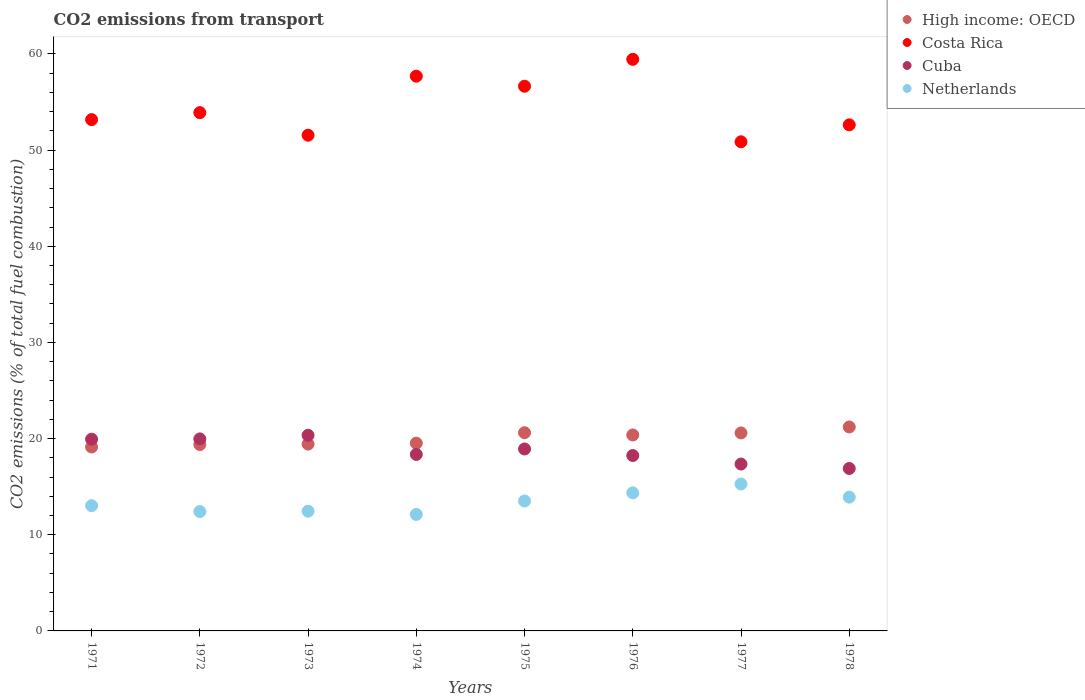What is the total CO2 emitted in High income: OECD in 1978?
Offer a very short reply. 21.21. Across all years, what is the maximum total CO2 emitted in Cuba?
Make the answer very short. 20.34. Across all years, what is the minimum total CO2 emitted in Cuba?
Give a very brief answer. 16.89. In which year was the total CO2 emitted in Costa Rica maximum?
Keep it short and to the point. 1976. In which year was the total CO2 emitted in Netherlands minimum?
Your answer should be compact. 1974. What is the total total CO2 emitted in High income: OECD in the graph?
Ensure brevity in your answer.  160.26. What is the difference between the total CO2 emitted in Netherlands in 1977 and that in 1978?
Offer a very short reply. 1.37. What is the difference between the total CO2 emitted in Netherlands in 1973 and the total CO2 emitted in High income: OECD in 1975?
Keep it short and to the point. -8.16. What is the average total CO2 emitted in Netherlands per year?
Provide a succinct answer. 13.38. In the year 1973, what is the difference between the total CO2 emitted in High income: OECD and total CO2 emitted in Cuba?
Keep it short and to the point. -0.92. What is the ratio of the total CO2 emitted in Netherlands in 1973 to that in 1974?
Ensure brevity in your answer.  1.03. Is the total CO2 emitted in Netherlands in 1974 less than that in 1975?
Offer a terse response. Yes. Is the difference between the total CO2 emitted in High income: OECD in 1974 and 1975 greater than the difference between the total CO2 emitted in Cuba in 1974 and 1975?
Offer a very short reply. No. What is the difference between the highest and the second highest total CO2 emitted in Netherlands?
Offer a very short reply. 0.92. What is the difference between the highest and the lowest total CO2 emitted in Costa Rica?
Your response must be concise. 8.57. Does the total CO2 emitted in Netherlands monotonically increase over the years?
Your answer should be compact. No. Is the total CO2 emitted in Cuba strictly less than the total CO2 emitted in Costa Rica over the years?
Provide a succinct answer. Yes. How many dotlines are there?
Keep it short and to the point. 4. How many years are there in the graph?
Ensure brevity in your answer.  8. What is the difference between two consecutive major ticks on the Y-axis?
Provide a short and direct response. 10. Does the graph contain grids?
Your answer should be compact. No. How many legend labels are there?
Provide a succinct answer. 4. What is the title of the graph?
Your answer should be compact. CO2 emissions from transport. Does "Euro area" appear as one of the legend labels in the graph?
Make the answer very short. No. What is the label or title of the X-axis?
Ensure brevity in your answer.  Years. What is the label or title of the Y-axis?
Provide a succinct answer. CO2 emissions (% of total fuel combustion). What is the CO2 emissions (% of total fuel combustion) of High income: OECD in 1971?
Provide a succinct answer. 19.13. What is the CO2 emissions (% of total fuel combustion) of Costa Rica in 1971?
Keep it short and to the point. 53.17. What is the CO2 emissions (% of total fuel combustion) in Cuba in 1971?
Your answer should be very brief. 19.94. What is the CO2 emissions (% of total fuel combustion) in Netherlands in 1971?
Keep it short and to the point. 13.03. What is the CO2 emissions (% of total fuel combustion) in High income: OECD in 1972?
Provide a succinct answer. 19.38. What is the CO2 emissions (% of total fuel combustion) in Costa Rica in 1972?
Make the answer very short. 53.9. What is the CO2 emissions (% of total fuel combustion) in Cuba in 1972?
Your response must be concise. 19.97. What is the CO2 emissions (% of total fuel combustion) of Netherlands in 1972?
Offer a very short reply. 12.41. What is the CO2 emissions (% of total fuel combustion) in High income: OECD in 1973?
Offer a terse response. 19.43. What is the CO2 emissions (% of total fuel combustion) in Costa Rica in 1973?
Offer a terse response. 51.55. What is the CO2 emissions (% of total fuel combustion) of Cuba in 1973?
Provide a succinct answer. 20.34. What is the CO2 emissions (% of total fuel combustion) in Netherlands in 1973?
Provide a succinct answer. 12.45. What is the CO2 emissions (% of total fuel combustion) in High income: OECD in 1974?
Your answer should be very brief. 19.52. What is the CO2 emissions (% of total fuel combustion) of Costa Rica in 1974?
Provide a succinct answer. 57.69. What is the CO2 emissions (% of total fuel combustion) of Cuba in 1974?
Your response must be concise. 18.35. What is the CO2 emissions (% of total fuel combustion) in Netherlands in 1974?
Your answer should be very brief. 12.12. What is the CO2 emissions (% of total fuel combustion) of High income: OECD in 1975?
Provide a short and direct response. 20.61. What is the CO2 emissions (% of total fuel combustion) of Costa Rica in 1975?
Your response must be concise. 56.65. What is the CO2 emissions (% of total fuel combustion) in Cuba in 1975?
Your response must be concise. 18.92. What is the CO2 emissions (% of total fuel combustion) of Netherlands in 1975?
Provide a short and direct response. 13.51. What is the CO2 emissions (% of total fuel combustion) of High income: OECD in 1976?
Provide a short and direct response. 20.38. What is the CO2 emissions (% of total fuel combustion) in Costa Rica in 1976?
Ensure brevity in your answer.  59.44. What is the CO2 emissions (% of total fuel combustion) in Cuba in 1976?
Provide a succinct answer. 18.24. What is the CO2 emissions (% of total fuel combustion) in Netherlands in 1976?
Keep it short and to the point. 14.36. What is the CO2 emissions (% of total fuel combustion) of High income: OECD in 1977?
Make the answer very short. 20.59. What is the CO2 emissions (% of total fuel combustion) of Costa Rica in 1977?
Your answer should be very brief. 50.87. What is the CO2 emissions (% of total fuel combustion) of Cuba in 1977?
Your answer should be compact. 17.35. What is the CO2 emissions (% of total fuel combustion) in Netherlands in 1977?
Your answer should be compact. 15.28. What is the CO2 emissions (% of total fuel combustion) in High income: OECD in 1978?
Offer a very short reply. 21.21. What is the CO2 emissions (% of total fuel combustion) in Costa Rica in 1978?
Your response must be concise. 52.63. What is the CO2 emissions (% of total fuel combustion) in Cuba in 1978?
Provide a short and direct response. 16.89. What is the CO2 emissions (% of total fuel combustion) of Netherlands in 1978?
Make the answer very short. 13.91. Across all years, what is the maximum CO2 emissions (% of total fuel combustion) of High income: OECD?
Your response must be concise. 21.21. Across all years, what is the maximum CO2 emissions (% of total fuel combustion) in Costa Rica?
Your answer should be very brief. 59.44. Across all years, what is the maximum CO2 emissions (% of total fuel combustion) of Cuba?
Give a very brief answer. 20.34. Across all years, what is the maximum CO2 emissions (% of total fuel combustion) in Netherlands?
Make the answer very short. 15.28. Across all years, what is the minimum CO2 emissions (% of total fuel combustion) in High income: OECD?
Offer a very short reply. 19.13. Across all years, what is the minimum CO2 emissions (% of total fuel combustion) of Costa Rica?
Provide a short and direct response. 50.87. Across all years, what is the minimum CO2 emissions (% of total fuel combustion) of Cuba?
Your response must be concise. 16.89. Across all years, what is the minimum CO2 emissions (% of total fuel combustion) in Netherlands?
Give a very brief answer. 12.12. What is the total CO2 emissions (% of total fuel combustion) of High income: OECD in the graph?
Provide a short and direct response. 160.26. What is the total CO2 emissions (% of total fuel combustion) of Costa Rica in the graph?
Your answer should be compact. 435.91. What is the total CO2 emissions (% of total fuel combustion) of Cuba in the graph?
Offer a terse response. 150.02. What is the total CO2 emissions (% of total fuel combustion) of Netherlands in the graph?
Offer a terse response. 107.07. What is the difference between the CO2 emissions (% of total fuel combustion) in High income: OECD in 1971 and that in 1972?
Keep it short and to the point. -0.25. What is the difference between the CO2 emissions (% of total fuel combustion) in Costa Rica in 1971 and that in 1972?
Make the answer very short. -0.73. What is the difference between the CO2 emissions (% of total fuel combustion) in Cuba in 1971 and that in 1972?
Make the answer very short. -0.03. What is the difference between the CO2 emissions (% of total fuel combustion) in Netherlands in 1971 and that in 1972?
Give a very brief answer. 0.61. What is the difference between the CO2 emissions (% of total fuel combustion) of Costa Rica in 1971 and that in 1973?
Your answer should be very brief. 1.62. What is the difference between the CO2 emissions (% of total fuel combustion) of Cuba in 1971 and that in 1973?
Offer a very short reply. -0.4. What is the difference between the CO2 emissions (% of total fuel combustion) in Netherlands in 1971 and that in 1973?
Your answer should be very brief. 0.58. What is the difference between the CO2 emissions (% of total fuel combustion) of High income: OECD in 1971 and that in 1974?
Offer a terse response. -0.4. What is the difference between the CO2 emissions (% of total fuel combustion) of Costa Rica in 1971 and that in 1974?
Keep it short and to the point. -4.52. What is the difference between the CO2 emissions (% of total fuel combustion) of Cuba in 1971 and that in 1974?
Give a very brief answer. 1.59. What is the difference between the CO2 emissions (% of total fuel combustion) of Netherlands in 1971 and that in 1974?
Your response must be concise. 0.91. What is the difference between the CO2 emissions (% of total fuel combustion) in High income: OECD in 1971 and that in 1975?
Offer a very short reply. -1.49. What is the difference between the CO2 emissions (% of total fuel combustion) of Costa Rica in 1971 and that in 1975?
Provide a succinct answer. -3.47. What is the difference between the CO2 emissions (% of total fuel combustion) of Cuba in 1971 and that in 1975?
Keep it short and to the point. 1.02. What is the difference between the CO2 emissions (% of total fuel combustion) in Netherlands in 1971 and that in 1975?
Make the answer very short. -0.48. What is the difference between the CO2 emissions (% of total fuel combustion) in High income: OECD in 1971 and that in 1976?
Ensure brevity in your answer.  -1.25. What is the difference between the CO2 emissions (% of total fuel combustion) of Costa Rica in 1971 and that in 1976?
Make the answer very short. -6.27. What is the difference between the CO2 emissions (% of total fuel combustion) of Cuba in 1971 and that in 1976?
Offer a very short reply. 1.7. What is the difference between the CO2 emissions (% of total fuel combustion) in Netherlands in 1971 and that in 1976?
Provide a succinct answer. -1.33. What is the difference between the CO2 emissions (% of total fuel combustion) of High income: OECD in 1971 and that in 1977?
Offer a very short reply. -1.46. What is the difference between the CO2 emissions (% of total fuel combustion) in Costa Rica in 1971 and that in 1977?
Provide a short and direct response. 2.31. What is the difference between the CO2 emissions (% of total fuel combustion) in Cuba in 1971 and that in 1977?
Keep it short and to the point. 2.59. What is the difference between the CO2 emissions (% of total fuel combustion) in Netherlands in 1971 and that in 1977?
Offer a very short reply. -2.25. What is the difference between the CO2 emissions (% of total fuel combustion) in High income: OECD in 1971 and that in 1978?
Provide a short and direct response. -2.08. What is the difference between the CO2 emissions (% of total fuel combustion) in Costa Rica in 1971 and that in 1978?
Keep it short and to the point. 0.54. What is the difference between the CO2 emissions (% of total fuel combustion) of Cuba in 1971 and that in 1978?
Offer a terse response. 3.05. What is the difference between the CO2 emissions (% of total fuel combustion) in Netherlands in 1971 and that in 1978?
Make the answer very short. -0.88. What is the difference between the CO2 emissions (% of total fuel combustion) of High income: OECD in 1972 and that in 1973?
Ensure brevity in your answer.  -0.05. What is the difference between the CO2 emissions (% of total fuel combustion) of Costa Rica in 1972 and that in 1973?
Keep it short and to the point. 2.35. What is the difference between the CO2 emissions (% of total fuel combustion) of Cuba in 1972 and that in 1973?
Make the answer very short. -0.37. What is the difference between the CO2 emissions (% of total fuel combustion) of Netherlands in 1972 and that in 1973?
Ensure brevity in your answer.  -0.04. What is the difference between the CO2 emissions (% of total fuel combustion) of High income: OECD in 1972 and that in 1974?
Give a very brief answer. -0.14. What is the difference between the CO2 emissions (% of total fuel combustion) in Costa Rica in 1972 and that in 1974?
Provide a short and direct response. -3.79. What is the difference between the CO2 emissions (% of total fuel combustion) in Cuba in 1972 and that in 1974?
Give a very brief answer. 1.62. What is the difference between the CO2 emissions (% of total fuel combustion) in Netherlands in 1972 and that in 1974?
Your answer should be very brief. 0.3. What is the difference between the CO2 emissions (% of total fuel combustion) in High income: OECD in 1972 and that in 1975?
Keep it short and to the point. -1.23. What is the difference between the CO2 emissions (% of total fuel combustion) of Costa Rica in 1972 and that in 1975?
Provide a short and direct response. -2.75. What is the difference between the CO2 emissions (% of total fuel combustion) of Cuba in 1972 and that in 1975?
Your answer should be very brief. 1.05. What is the difference between the CO2 emissions (% of total fuel combustion) of Netherlands in 1972 and that in 1975?
Make the answer very short. -1.1. What is the difference between the CO2 emissions (% of total fuel combustion) of High income: OECD in 1972 and that in 1976?
Offer a very short reply. -1. What is the difference between the CO2 emissions (% of total fuel combustion) in Costa Rica in 1972 and that in 1976?
Your answer should be compact. -5.54. What is the difference between the CO2 emissions (% of total fuel combustion) in Cuba in 1972 and that in 1976?
Ensure brevity in your answer.  1.73. What is the difference between the CO2 emissions (% of total fuel combustion) in Netherlands in 1972 and that in 1976?
Your answer should be very brief. -1.95. What is the difference between the CO2 emissions (% of total fuel combustion) in High income: OECD in 1972 and that in 1977?
Give a very brief answer. -1.21. What is the difference between the CO2 emissions (% of total fuel combustion) of Costa Rica in 1972 and that in 1977?
Keep it short and to the point. 3.03. What is the difference between the CO2 emissions (% of total fuel combustion) of Cuba in 1972 and that in 1977?
Your answer should be compact. 2.62. What is the difference between the CO2 emissions (% of total fuel combustion) in Netherlands in 1972 and that in 1977?
Your answer should be very brief. -2.86. What is the difference between the CO2 emissions (% of total fuel combustion) of High income: OECD in 1972 and that in 1978?
Your answer should be compact. -1.83. What is the difference between the CO2 emissions (% of total fuel combustion) of Costa Rica in 1972 and that in 1978?
Your answer should be compact. 1.27. What is the difference between the CO2 emissions (% of total fuel combustion) of Cuba in 1972 and that in 1978?
Keep it short and to the point. 3.08. What is the difference between the CO2 emissions (% of total fuel combustion) of Netherlands in 1972 and that in 1978?
Ensure brevity in your answer.  -1.5. What is the difference between the CO2 emissions (% of total fuel combustion) in High income: OECD in 1973 and that in 1974?
Keep it short and to the point. -0.1. What is the difference between the CO2 emissions (% of total fuel combustion) in Costa Rica in 1973 and that in 1974?
Offer a very short reply. -6.14. What is the difference between the CO2 emissions (% of total fuel combustion) of Cuba in 1973 and that in 1974?
Keep it short and to the point. 1.99. What is the difference between the CO2 emissions (% of total fuel combustion) of Netherlands in 1973 and that in 1974?
Provide a short and direct response. 0.33. What is the difference between the CO2 emissions (% of total fuel combustion) of High income: OECD in 1973 and that in 1975?
Provide a short and direct response. -1.19. What is the difference between the CO2 emissions (% of total fuel combustion) of Costa Rica in 1973 and that in 1975?
Give a very brief answer. -5.09. What is the difference between the CO2 emissions (% of total fuel combustion) in Cuba in 1973 and that in 1975?
Your answer should be compact. 1.42. What is the difference between the CO2 emissions (% of total fuel combustion) in Netherlands in 1973 and that in 1975?
Offer a terse response. -1.06. What is the difference between the CO2 emissions (% of total fuel combustion) of High income: OECD in 1973 and that in 1976?
Offer a very short reply. -0.95. What is the difference between the CO2 emissions (% of total fuel combustion) in Costa Rica in 1973 and that in 1976?
Your answer should be very brief. -7.89. What is the difference between the CO2 emissions (% of total fuel combustion) of Cuba in 1973 and that in 1976?
Your response must be concise. 2.1. What is the difference between the CO2 emissions (% of total fuel combustion) in Netherlands in 1973 and that in 1976?
Your answer should be compact. -1.91. What is the difference between the CO2 emissions (% of total fuel combustion) in High income: OECD in 1973 and that in 1977?
Provide a succinct answer. -1.16. What is the difference between the CO2 emissions (% of total fuel combustion) in Costa Rica in 1973 and that in 1977?
Offer a terse response. 0.68. What is the difference between the CO2 emissions (% of total fuel combustion) in Cuba in 1973 and that in 1977?
Provide a short and direct response. 2.99. What is the difference between the CO2 emissions (% of total fuel combustion) of Netherlands in 1973 and that in 1977?
Your answer should be very brief. -2.83. What is the difference between the CO2 emissions (% of total fuel combustion) of High income: OECD in 1973 and that in 1978?
Your response must be concise. -1.78. What is the difference between the CO2 emissions (% of total fuel combustion) of Costa Rica in 1973 and that in 1978?
Offer a very short reply. -1.08. What is the difference between the CO2 emissions (% of total fuel combustion) in Cuba in 1973 and that in 1978?
Offer a terse response. 3.45. What is the difference between the CO2 emissions (% of total fuel combustion) in Netherlands in 1973 and that in 1978?
Provide a short and direct response. -1.46. What is the difference between the CO2 emissions (% of total fuel combustion) in High income: OECD in 1974 and that in 1975?
Your response must be concise. -1.09. What is the difference between the CO2 emissions (% of total fuel combustion) of Costa Rica in 1974 and that in 1975?
Offer a very short reply. 1.04. What is the difference between the CO2 emissions (% of total fuel combustion) of Cuba in 1974 and that in 1975?
Your answer should be very brief. -0.57. What is the difference between the CO2 emissions (% of total fuel combustion) of Netherlands in 1974 and that in 1975?
Offer a terse response. -1.4. What is the difference between the CO2 emissions (% of total fuel combustion) of High income: OECD in 1974 and that in 1976?
Your answer should be compact. -0.85. What is the difference between the CO2 emissions (% of total fuel combustion) of Costa Rica in 1974 and that in 1976?
Your response must be concise. -1.75. What is the difference between the CO2 emissions (% of total fuel combustion) in Cuba in 1974 and that in 1976?
Provide a succinct answer. 0.11. What is the difference between the CO2 emissions (% of total fuel combustion) in Netherlands in 1974 and that in 1976?
Offer a terse response. -2.24. What is the difference between the CO2 emissions (% of total fuel combustion) of High income: OECD in 1974 and that in 1977?
Your response must be concise. -1.07. What is the difference between the CO2 emissions (% of total fuel combustion) in Costa Rica in 1974 and that in 1977?
Give a very brief answer. 6.82. What is the difference between the CO2 emissions (% of total fuel combustion) of Cuba in 1974 and that in 1977?
Provide a succinct answer. 1. What is the difference between the CO2 emissions (% of total fuel combustion) in Netherlands in 1974 and that in 1977?
Ensure brevity in your answer.  -3.16. What is the difference between the CO2 emissions (% of total fuel combustion) of High income: OECD in 1974 and that in 1978?
Give a very brief answer. -1.69. What is the difference between the CO2 emissions (% of total fuel combustion) in Costa Rica in 1974 and that in 1978?
Provide a succinct answer. 5.06. What is the difference between the CO2 emissions (% of total fuel combustion) in Cuba in 1974 and that in 1978?
Keep it short and to the point. 1.46. What is the difference between the CO2 emissions (% of total fuel combustion) of Netherlands in 1974 and that in 1978?
Keep it short and to the point. -1.8. What is the difference between the CO2 emissions (% of total fuel combustion) in High income: OECD in 1975 and that in 1976?
Keep it short and to the point. 0.24. What is the difference between the CO2 emissions (% of total fuel combustion) of Costa Rica in 1975 and that in 1976?
Your answer should be compact. -2.8. What is the difference between the CO2 emissions (% of total fuel combustion) in Cuba in 1975 and that in 1976?
Your response must be concise. 0.68. What is the difference between the CO2 emissions (% of total fuel combustion) in Netherlands in 1975 and that in 1976?
Make the answer very short. -0.85. What is the difference between the CO2 emissions (% of total fuel combustion) of High income: OECD in 1975 and that in 1977?
Your answer should be very brief. 0.02. What is the difference between the CO2 emissions (% of total fuel combustion) in Costa Rica in 1975 and that in 1977?
Offer a very short reply. 5.78. What is the difference between the CO2 emissions (% of total fuel combustion) of Cuba in 1975 and that in 1977?
Offer a terse response. 1.57. What is the difference between the CO2 emissions (% of total fuel combustion) of Netherlands in 1975 and that in 1977?
Provide a succinct answer. -1.77. What is the difference between the CO2 emissions (% of total fuel combustion) in High income: OECD in 1975 and that in 1978?
Your answer should be compact. -0.6. What is the difference between the CO2 emissions (% of total fuel combustion) in Costa Rica in 1975 and that in 1978?
Offer a terse response. 4.02. What is the difference between the CO2 emissions (% of total fuel combustion) of Cuba in 1975 and that in 1978?
Give a very brief answer. 2.03. What is the difference between the CO2 emissions (% of total fuel combustion) in Netherlands in 1975 and that in 1978?
Your response must be concise. -0.4. What is the difference between the CO2 emissions (% of total fuel combustion) in High income: OECD in 1976 and that in 1977?
Make the answer very short. -0.21. What is the difference between the CO2 emissions (% of total fuel combustion) of Costa Rica in 1976 and that in 1977?
Offer a terse response. 8.57. What is the difference between the CO2 emissions (% of total fuel combustion) of Cuba in 1976 and that in 1977?
Ensure brevity in your answer.  0.89. What is the difference between the CO2 emissions (% of total fuel combustion) in Netherlands in 1976 and that in 1977?
Keep it short and to the point. -0.92. What is the difference between the CO2 emissions (% of total fuel combustion) in High income: OECD in 1976 and that in 1978?
Make the answer very short. -0.83. What is the difference between the CO2 emissions (% of total fuel combustion) in Costa Rica in 1976 and that in 1978?
Your answer should be compact. 6.81. What is the difference between the CO2 emissions (% of total fuel combustion) in Cuba in 1976 and that in 1978?
Your answer should be compact. 1.35. What is the difference between the CO2 emissions (% of total fuel combustion) of Netherlands in 1976 and that in 1978?
Your answer should be compact. 0.45. What is the difference between the CO2 emissions (% of total fuel combustion) in High income: OECD in 1977 and that in 1978?
Keep it short and to the point. -0.62. What is the difference between the CO2 emissions (% of total fuel combustion) in Costa Rica in 1977 and that in 1978?
Ensure brevity in your answer.  -1.76. What is the difference between the CO2 emissions (% of total fuel combustion) of Cuba in 1977 and that in 1978?
Provide a succinct answer. 0.46. What is the difference between the CO2 emissions (% of total fuel combustion) in Netherlands in 1977 and that in 1978?
Give a very brief answer. 1.37. What is the difference between the CO2 emissions (% of total fuel combustion) of High income: OECD in 1971 and the CO2 emissions (% of total fuel combustion) of Costa Rica in 1972?
Keep it short and to the point. -34.77. What is the difference between the CO2 emissions (% of total fuel combustion) in High income: OECD in 1971 and the CO2 emissions (% of total fuel combustion) in Cuba in 1972?
Keep it short and to the point. -0.84. What is the difference between the CO2 emissions (% of total fuel combustion) in High income: OECD in 1971 and the CO2 emissions (% of total fuel combustion) in Netherlands in 1972?
Provide a succinct answer. 6.72. What is the difference between the CO2 emissions (% of total fuel combustion) in Costa Rica in 1971 and the CO2 emissions (% of total fuel combustion) in Cuba in 1972?
Provide a succinct answer. 33.2. What is the difference between the CO2 emissions (% of total fuel combustion) in Costa Rica in 1971 and the CO2 emissions (% of total fuel combustion) in Netherlands in 1972?
Give a very brief answer. 40.76. What is the difference between the CO2 emissions (% of total fuel combustion) in Cuba in 1971 and the CO2 emissions (% of total fuel combustion) in Netherlands in 1972?
Offer a very short reply. 7.53. What is the difference between the CO2 emissions (% of total fuel combustion) in High income: OECD in 1971 and the CO2 emissions (% of total fuel combustion) in Costa Rica in 1973?
Your answer should be very brief. -32.42. What is the difference between the CO2 emissions (% of total fuel combustion) of High income: OECD in 1971 and the CO2 emissions (% of total fuel combustion) of Cuba in 1973?
Give a very brief answer. -1.22. What is the difference between the CO2 emissions (% of total fuel combustion) of High income: OECD in 1971 and the CO2 emissions (% of total fuel combustion) of Netherlands in 1973?
Your answer should be compact. 6.68. What is the difference between the CO2 emissions (% of total fuel combustion) in Costa Rica in 1971 and the CO2 emissions (% of total fuel combustion) in Cuba in 1973?
Keep it short and to the point. 32.83. What is the difference between the CO2 emissions (% of total fuel combustion) of Costa Rica in 1971 and the CO2 emissions (% of total fuel combustion) of Netherlands in 1973?
Your answer should be compact. 40.72. What is the difference between the CO2 emissions (% of total fuel combustion) of Cuba in 1971 and the CO2 emissions (% of total fuel combustion) of Netherlands in 1973?
Offer a terse response. 7.49. What is the difference between the CO2 emissions (% of total fuel combustion) in High income: OECD in 1971 and the CO2 emissions (% of total fuel combustion) in Costa Rica in 1974?
Your response must be concise. -38.56. What is the difference between the CO2 emissions (% of total fuel combustion) in High income: OECD in 1971 and the CO2 emissions (% of total fuel combustion) in Cuba in 1974?
Offer a very short reply. 0.78. What is the difference between the CO2 emissions (% of total fuel combustion) in High income: OECD in 1971 and the CO2 emissions (% of total fuel combustion) in Netherlands in 1974?
Your answer should be compact. 7.01. What is the difference between the CO2 emissions (% of total fuel combustion) in Costa Rica in 1971 and the CO2 emissions (% of total fuel combustion) in Cuba in 1974?
Make the answer very short. 34.82. What is the difference between the CO2 emissions (% of total fuel combustion) in Costa Rica in 1971 and the CO2 emissions (% of total fuel combustion) in Netherlands in 1974?
Offer a very short reply. 41.06. What is the difference between the CO2 emissions (% of total fuel combustion) in Cuba in 1971 and the CO2 emissions (% of total fuel combustion) in Netherlands in 1974?
Your answer should be very brief. 7.83. What is the difference between the CO2 emissions (% of total fuel combustion) in High income: OECD in 1971 and the CO2 emissions (% of total fuel combustion) in Costa Rica in 1975?
Offer a very short reply. -37.52. What is the difference between the CO2 emissions (% of total fuel combustion) of High income: OECD in 1971 and the CO2 emissions (% of total fuel combustion) of Cuba in 1975?
Provide a succinct answer. 0.21. What is the difference between the CO2 emissions (% of total fuel combustion) of High income: OECD in 1971 and the CO2 emissions (% of total fuel combustion) of Netherlands in 1975?
Your response must be concise. 5.62. What is the difference between the CO2 emissions (% of total fuel combustion) in Costa Rica in 1971 and the CO2 emissions (% of total fuel combustion) in Cuba in 1975?
Offer a terse response. 34.25. What is the difference between the CO2 emissions (% of total fuel combustion) of Costa Rica in 1971 and the CO2 emissions (% of total fuel combustion) of Netherlands in 1975?
Keep it short and to the point. 39.66. What is the difference between the CO2 emissions (% of total fuel combustion) of Cuba in 1971 and the CO2 emissions (% of total fuel combustion) of Netherlands in 1975?
Provide a short and direct response. 6.43. What is the difference between the CO2 emissions (% of total fuel combustion) of High income: OECD in 1971 and the CO2 emissions (% of total fuel combustion) of Costa Rica in 1976?
Keep it short and to the point. -40.32. What is the difference between the CO2 emissions (% of total fuel combustion) of High income: OECD in 1971 and the CO2 emissions (% of total fuel combustion) of Netherlands in 1976?
Your answer should be compact. 4.77. What is the difference between the CO2 emissions (% of total fuel combustion) in Costa Rica in 1971 and the CO2 emissions (% of total fuel combustion) in Cuba in 1976?
Provide a succinct answer. 34.93. What is the difference between the CO2 emissions (% of total fuel combustion) of Costa Rica in 1971 and the CO2 emissions (% of total fuel combustion) of Netherlands in 1976?
Keep it short and to the point. 38.82. What is the difference between the CO2 emissions (% of total fuel combustion) of Cuba in 1971 and the CO2 emissions (% of total fuel combustion) of Netherlands in 1976?
Offer a very short reply. 5.58. What is the difference between the CO2 emissions (% of total fuel combustion) in High income: OECD in 1971 and the CO2 emissions (% of total fuel combustion) in Costa Rica in 1977?
Give a very brief answer. -31.74. What is the difference between the CO2 emissions (% of total fuel combustion) of High income: OECD in 1971 and the CO2 emissions (% of total fuel combustion) of Cuba in 1977?
Your answer should be very brief. 1.78. What is the difference between the CO2 emissions (% of total fuel combustion) of High income: OECD in 1971 and the CO2 emissions (% of total fuel combustion) of Netherlands in 1977?
Keep it short and to the point. 3.85. What is the difference between the CO2 emissions (% of total fuel combustion) of Costa Rica in 1971 and the CO2 emissions (% of total fuel combustion) of Cuba in 1977?
Ensure brevity in your answer.  35.82. What is the difference between the CO2 emissions (% of total fuel combustion) in Costa Rica in 1971 and the CO2 emissions (% of total fuel combustion) in Netherlands in 1977?
Provide a short and direct response. 37.9. What is the difference between the CO2 emissions (% of total fuel combustion) in Cuba in 1971 and the CO2 emissions (% of total fuel combustion) in Netherlands in 1977?
Provide a short and direct response. 4.66. What is the difference between the CO2 emissions (% of total fuel combustion) of High income: OECD in 1971 and the CO2 emissions (% of total fuel combustion) of Costa Rica in 1978?
Provide a succinct answer. -33.5. What is the difference between the CO2 emissions (% of total fuel combustion) in High income: OECD in 1971 and the CO2 emissions (% of total fuel combustion) in Cuba in 1978?
Make the answer very short. 2.24. What is the difference between the CO2 emissions (% of total fuel combustion) in High income: OECD in 1971 and the CO2 emissions (% of total fuel combustion) in Netherlands in 1978?
Keep it short and to the point. 5.22. What is the difference between the CO2 emissions (% of total fuel combustion) of Costa Rica in 1971 and the CO2 emissions (% of total fuel combustion) of Cuba in 1978?
Provide a short and direct response. 36.28. What is the difference between the CO2 emissions (% of total fuel combustion) of Costa Rica in 1971 and the CO2 emissions (% of total fuel combustion) of Netherlands in 1978?
Offer a terse response. 39.26. What is the difference between the CO2 emissions (% of total fuel combustion) of Cuba in 1971 and the CO2 emissions (% of total fuel combustion) of Netherlands in 1978?
Ensure brevity in your answer.  6.03. What is the difference between the CO2 emissions (% of total fuel combustion) in High income: OECD in 1972 and the CO2 emissions (% of total fuel combustion) in Costa Rica in 1973?
Give a very brief answer. -32.17. What is the difference between the CO2 emissions (% of total fuel combustion) in High income: OECD in 1972 and the CO2 emissions (% of total fuel combustion) in Cuba in 1973?
Your answer should be compact. -0.96. What is the difference between the CO2 emissions (% of total fuel combustion) of High income: OECD in 1972 and the CO2 emissions (% of total fuel combustion) of Netherlands in 1973?
Offer a very short reply. 6.93. What is the difference between the CO2 emissions (% of total fuel combustion) in Costa Rica in 1972 and the CO2 emissions (% of total fuel combustion) in Cuba in 1973?
Keep it short and to the point. 33.56. What is the difference between the CO2 emissions (% of total fuel combustion) of Costa Rica in 1972 and the CO2 emissions (% of total fuel combustion) of Netherlands in 1973?
Your answer should be very brief. 41.45. What is the difference between the CO2 emissions (% of total fuel combustion) in Cuba in 1972 and the CO2 emissions (% of total fuel combustion) in Netherlands in 1973?
Ensure brevity in your answer.  7.52. What is the difference between the CO2 emissions (% of total fuel combustion) in High income: OECD in 1972 and the CO2 emissions (% of total fuel combustion) in Costa Rica in 1974?
Your answer should be compact. -38.31. What is the difference between the CO2 emissions (% of total fuel combustion) in High income: OECD in 1972 and the CO2 emissions (% of total fuel combustion) in Cuba in 1974?
Your answer should be very brief. 1.03. What is the difference between the CO2 emissions (% of total fuel combustion) in High income: OECD in 1972 and the CO2 emissions (% of total fuel combustion) in Netherlands in 1974?
Offer a terse response. 7.27. What is the difference between the CO2 emissions (% of total fuel combustion) of Costa Rica in 1972 and the CO2 emissions (% of total fuel combustion) of Cuba in 1974?
Ensure brevity in your answer.  35.55. What is the difference between the CO2 emissions (% of total fuel combustion) of Costa Rica in 1972 and the CO2 emissions (% of total fuel combustion) of Netherlands in 1974?
Make the answer very short. 41.79. What is the difference between the CO2 emissions (% of total fuel combustion) of Cuba in 1972 and the CO2 emissions (% of total fuel combustion) of Netherlands in 1974?
Make the answer very short. 7.85. What is the difference between the CO2 emissions (% of total fuel combustion) in High income: OECD in 1972 and the CO2 emissions (% of total fuel combustion) in Costa Rica in 1975?
Make the answer very short. -37.27. What is the difference between the CO2 emissions (% of total fuel combustion) in High income: OECD in 1972 and the CO2 emissions (% of total fuel combustion) in Cuba in 1975?
Provide a short and direct response. 0.46. What is the difference between the CO2 emissions (% of total fuel combustion) in High income: OECD in 1972 and the CO2 emissions (% of total fuel combustion) in Netherlands in 1975?
Your answer should be very brief. 5.87. What is the difference between the CO2 emissions (% of total fuel combustion) of Costa Rica in 1972 and the CO2 emissions (% of total fuel combustion) of Cuba in 1975?
Offer a very short reply. 34.98. What is the difference between the CO2 emissions (% of total fuel combustion) in Costa Rica in 1972 and the CO2 emissions (% of total fuel combustion) in Netherlands in 1975?
Give a very brief answer. 40.39. What is the difference between the CO2 emissions (% of total fuel combustion) in Cuba in 1972 and the CO2 emissions (% of total fuel combustion) in Netherlands in 1975?
Provide a short and direct response. 6.46. What is the difference between the CO2 emissions (% of total fuel combustion) in High income: OECD in 1972 and the CO2 emissions (% of total fuel combustion) in Costa Rica in 1976?
Offer a terse response. -40.06. What is the difference between the CO2 emissions (% of total fuel combustion) of High income: OECD in 1972 and the CO2 emissions (% of total fuel combustion) of Cuba in 1976?
Provide a short and direct response. 1.14. What is the difference between the CO2 emissions (% of total fuel combustion) of High income: OECD in 1972 and the CO2 emissions (% of total fuel combustion) of Netherlands in 1976?
Ensure brevity in your answer.  5.02. What is the difference between the CO2 emissions (% of total fuel combustion) of Costa Rica in 1972 and the CO2 emissions (% of total fuel combustion) of Cuba in 1976?
Offer a terse response. 35.66. What is the difference between the CO2 emissions (% of total fuel combustion) of Costa Rica in 1972 and the CO2 emissions (% of total fuel combustion) of Netherlands in 1976?
Your answer should be very brief. 39.54. What is the difference between the CO2 emissions (% of total fuel combustion) in Cuba in 1972 and the CO2 emissions (% of total fuel combustion) in Netherlands in 1976?
Keep it short and to the point. 5.61. What is the difference between the CO2 emissions (% of total fuel combustion) in High income: OECD in 1972 and the CO2 emissions (% of total fuel combustion) in Costa Rica in 1977?
Provide a succinct answer. -31.49. What is the difference between the CO2 emissions (% of total fuel combustion) in High income: OECD in 1972 and the CO2 emissions (% of total fuel combustion) in Cuba in 1977?
Keep it short and to the point. 2.03. What is the difference between the CO2 emissions (% of total fuel combustion) of High income: OECD in 1972 and the CO2 emissions (% of total fuel combustion) of Netherlands in 1977?
Provide a short and direct response. 4.1. What is the difference between the CO2 emissions (% of total fuel combustion) in Costa Rica in 1972 and the CO2 emissions (% of total fuel combustion) in Cuba in 1977?
Provide a short and direct response. 36.55. What is the difference between the CO2 emissions (% of total fuel combustion) in Costa Rica in 1972 and the CO2 emissions (% of total fuel combustion) in Netherlands in 1977?
Your answer should be very brief. 38.62. What is the difference between the CO2 emissions (% of total fuel combustion) in Cuba in 1972 and the CO2 emissions (% of total fuel combustion) in Netherlands in 1977?
Offer a very short reply. 4.69. What is the difference between the CO2 emissions (% of total fuel combustion) in High income: OECD in 1972 and the CO2 emissions (% of total fuel combustion) in Costa Rica in 1978?
Make the answer very short. -33.25. What is the difference between the CO2 emissions (% of total fuel combustion) of High income: OECD in 1972 and the CO2 emissions (% of total fuel combustion) of Cuba in 1978?
Offer a very short reply. 2.49. What is the difference between the CO2 emissions (% of total fuel combustion) in High income: OECD in 1972 and the CO2 emissions (% of total fuel combustion) in Netherlands in 1978?
Give a very brief answer. 5.47. What is the difference between the CO2 emissions (% of total fuel combustion) in Costa Rica in 1972 and the CO2 emissions (% of total fuel combustion) in Cuba in 1978?
Keep it short and to the point. 37.01. What is the difference between the CO2 emissions (% of total fuel combustion) in Costa Rica in 1972 and the CO2 emissions (% of total fuel combustion) in Netherlands in 1978?
Give a very brief answer. 39.99. What is the difference between the CO2 emissions (% of total fuel combustion) in Cuba in 1972 and the CO2 emissions (% of total fuel combustion) in Netherlands in 1978?
Your answer should be compact. 6.06. What is the difference between the CO2 emissions (% of total fuel combustion) of High income: OECD in 1973 and the CO2 emissions (% of total fuel combustion) of Costa Rica in 1974?
Provide a short and direct response. -38.26. What is the difference between the CO2 emissions (% of total fuel combustion) of High income: OECD in 1973 and the CO2 emissions (% of total fuel combustion) of Cuba in 1974?
Your answer should be compact. 1.08. What is the difference between the CO2 emissions (% of total fuel combustion) in High income: OECD in 1973 and the CO2 emissions (% of total fuel combustion) in Netherlands in 1974?
Provide a short and direct response. 7.31. What is the difference between the CO2 emissions (% of total fuel combustion) in Costa Rica in 1973 and the CO2 emissions (% of total fuel combustion) in Cuba in 1974?
Provide a succinct answer. 33.2. What is the difference between the CO2 emissions (% of total fuel combustion) in Costa Rica in 1973 and the CO2 emissions (% of total fuel combustion) in Netherlands in 1974?
Ensure brevity in your answer.  39.44. What is the difference between the CO2 emissions (% of total fuel combustion) of Cuba in 1973 and the CO2 emissions (% of total fuel combustion) of Netherlands in 1974?
Provide a succinct answer. 8.23. What is the difference between the CO2 emissions (% of total fuel combustion) in High income: OECD in 1973 and the CO2 emissions (% of total fuel combustion) in Costa Rica in 1975?
Offer a very short reply. -37.22. What is the difference between the CO2 emissions (% of total fuel combustion) in High income: OECD in 1973 and the CO2 emissions (% of total fuel combustion) in Cuba in 1975?
Keep it short and to the point. 0.51. What is the difference between the CO2 emissions (% of total fuel combustion) in High income: OECD in 1973 and the CO2 emissions (% of total fuel combustion) in Netherlands in 1975?
Keep it short and to the point. 5.92. What is the difference between the CO2 emissions (% of total fuel combustion) in Costa Rica in 1973 and the CO2 emissions (% of total fuel combustion) in Cuba in 1975?
Your answer should be very brief. 32.63. What is the difference between the CO2 emissions (% of total fuel combustion) of Costa Rica in 1973 and the CO2 emissions (% of total fuel combustion) of Netherlands in 1975?
Ensure brevity in your answer.  38.04. What is the difference between the CO2 emissions (% of total fuel combustion) of Cuba in 1973 and the CO2 emissions (% of total fuel combustion) of Netherlands in 1975?
Offer a very short reply. 6.83. What is the difference between the CO2 emissions (% of total fuel combustion) in High income: OECD in 1973 and the CO2 emissions (% of total fuel combustion) in Costa Rica in 1976?
Your answer should be compact. -40.02. What is the difference between the CO2 emissions (% of total fuel combustion) of High income: OECD in 1973 and the CO2 emissions (% of total fuel combustion) of Cuba in 1976?
Offer a terse response. 1.19. What is the difference between the CO2 emissions (% of total fuel combustion) in High income: OECD in 1973 and the CO2 emissions (% of total fuel combustion) in Netherlands in 1976?
Offer a terse response. 5.07. What is the difference between the CO2 emissions (% of total fuel combustion) in Costa Rica in 1973 and the CO2 emissions (% of total fuel combustion) in Cuba in 1976?
Give a very brief answer. 33.31. What is the difference between the CO2 emissions (% of total fuel combustion) in Costa Rica in 1973 and the CO2 emissions (% of total fuel combustion) in Netherlands in 1976?
Your response must be concise. 37.19. What is the difference between the CO2 emissions (% of total fuel combustion) in Cuba in 1973 and the CO2 emissions (% of total fuel combustion) in Netherlands in 1976?
Keep it short and to the point. 5.99. What is the difference between the CO2 emissions (% of total fuel combustion) in High income: OECD in 1973 and the CO2 emissions (% of total fuel combustion) in Costa Rica in 1977?
Give a very brief answer. -31.44. What is the difference between the CO2 emissions (% of total fuel combustion) of High income: OECD in 1973 and the CO2 emissions (% of total fuel combustion) of Cuba in 1977?
Your answer should be very brief. 2.08. What is the difference between the CO2 emissions (% of total fuel combustion) of High income: OECD in 1973 and the CO2 emissions (% of total fuel combustion) of Netherlands in 1977?
Your response must be concise. 4.15. What is the difference between the CO2 emissions (% of total fuel combustion) of Costa Rica in 1973 and the CO2 emissions (% of total fuel combustion) of Cuba in 1977?
Offer a very short reply. 34.2. What is the difference between the CO2 emissions (% of total fuel combustion) in Costa Rica in 1973 and the CO2 emissions (% of total fuel combustion) in Netherlands in 1977?
Offer a terse response. 36.27. What is the difference between the CO2 emissions (% of total fuel combustion) of Cuba in 1973 and the CO2 emissions (% of total fuel combustion) of Netherlands in 1977?
Offer a terse response. 5.07. What is the difference between the CO2 emissions (% of total fuel combustion) in High income: OECD in 1973 and the CO2 emissions (% of total fuel combustion) in Costa Rica in 1978?
Your response must be concise. -33.2. What is the difference between the CO2 emissions (% of total fuel combustion) of High income: OECD in 1973 and the CO2 emissions (% of total fuel combustion) of Cuba in 1978?
Your response must be concise. 2.54. What is the difference between the CO2 emissions (% of total fuel combustion) of High income: OECD in 1973 and the CO2 emissions (% of total fuel combustion) of Netherlands in 1978?
Provide a short and direct response. 5.52. What is the difference between the CO2 emissions (% of total fuel combustion) of Costa Rica in 1973 and the CO2 emissions (% of total fuel combustion) of Cuba in 1978?
Offer a terse response. 34.66. What is the difference between the CO2 emissions (% of total fuel combustion) in Costa Rica in 1973 and the CO2 emissions (% of total fuel combustion) in Netherlands in 1978?
Offer a very short reply. 37.64. What is the difference between the CO2 emissions (% of total fuel combustion) in Cuba in 1973 and the CO2 emissions (% of total fuel combustion) in Netherlands in 1978?
Provide a succinct answer. 6.43. What is the difference between the CO2 emissions (% of total fuel combustion) in High income: OECD in 1974 and the CO2 emissions (% of total fuel combustion) in Costa Rica in 1975?
Give a very brief answer. -37.12. What is the difference between the CO2 emissions (% of total fuel combustion) in High income: OECD in 1974 and the CO2 emissions (% of total fuel combustion) in Cuba in 1975?
Your answer should be very brief. 0.6. What is the difference between the CO2 emissions (% of total fuel combustion) of High income: OECD in 1974 and the CO2 emissions (% of total fuel combustion) of Netherlands in 1975?
Your response must be concise. 6.01. What is the difference between the CO2 emissions (% of total fuel combustion) in Costa Rica in 1974 and the CO2 emissions (% of total fuel combustion) in Cuba in 1975?
Keep it short and to the point. 38.77. What is the difference between the CO2 emissions (% of total fuel combustion) of Costa Rica in 1974 and the CO2 emissions (% of total fuel combustion) of Netherlands in 1975?
Provide a short and direct response. 44.18. What is the difference between the CO2 emissions (% of total fuel combustion) in Cuba in 1974 and the CO2 emissions (% of total fuel combustion) in Netherlands in 1975?
Ensure brevity in your answer.  4.84. What is the difference between the CO2 emissions (% of total fuel combustion) of High income: OECD in 1974 and the CO2 emissions (% of total fuel combustion) of Costa Rica in 1976?
Keep it short and to the point. -39.92. What is the difference between the CO2 emissions (% of total fuel combustion) of High income: OECD in 1974 and the CO2 emissions (% of total fuel combustion) of Cuba in 1976?
Offer a terse response. 1.28. What is the difference between the CO2 emissions (% of total fuel combustion) in High income: OECD in 1974 and the CO2 emissions (% of total fuel combustion) in Netherlands in 1976?
Provide a short and direct response. 5.16. What is the difference between the CO2 emissions (% of total fuel combustion) of Costa Rica in 1974 and the CO2 emissions (% of total fuel combustion) of Cuba in 1976?
Provide a short and direct response. 39.45. What is the difference between the CO2 emissions (% of total fuel combustion) in Costa Rica in 1974 and the CO2 emissions (% of total fuel combustion) in Netherlands in 1976?
Make the answer very short. 43.33. What is the difference between the CO2 emissions (% of total fuel combustion) of Cuba in 1974 and the CO2 emissions (% of total fuel combustion) of Netherlands in 1976?
Offer a very short reply. 3.99. What is the difference between the CO2 emissions (% of total fuel combustion) in High income: OECD in 1974 and the CO2 emissions (% of total fuel combustion) in Costa Rica in 1977?
Offer a terse response. -31.35. What is the difference between the CO2 emissions (% of total fuel combustion) in High income: OECD in 1974 and the CO2 emissions (% of total fuel combustion) in Cuba in 1977?
Your answer should be very brief. 2.17. What is the difference between the CO2 emissions (% of total fuel combustion) in High income: OECD in 1974 and the CO2 emissions (% of total fuel combustion) in Netherlands in 1977?
Keep it short and to the point. 4.25. What is the difference between the CO2 emissions (% of total fuel combustion) in Costa Rica in 1974 and the CO2 emissions (% of total fuel combustion) in Cuba in 1977?
Ensure brevity in your answer.  40.34. What is the difference between the CO2 emissions (% of total fuel combustion) in Costa Rica in 1974 and the CO2 emissions (% of total fuel combustion) in Netherlands in 1977?
Provide a short and direct response. 42.41. What is the difference between the CO2 emissions (% of total fuel combustion) in Cuba in 1974 and the CO2 emissions (% of total fuel combustion) in Netherlands in 1977?
Offer a terse response. 3.08. What is the difference between the CO2 emissions (% of total fuel combustion) in High income: OECD in 1974 and the CO2 emissions (% of total fuel combustion) in Costa Rica in 1978?
Offer a very short reply. -33.11. What is the difference between the CO2 emissions (% of total fuel combustion) in High income: OECD in 1974 and the CO2 emissions (% of total fuel combustion) in Cuba in 1978?
Your response must be concise. 2.63. What is the difference between the CO2 emissions (% of total fuel combustion) of High income: OECD in 1974 and the CO2 emissions (% of total fuel combustion) of Netherlands in 1978?
Your response must be concise. 5.61. What is the difference between the CO2 emissions (% of total fuel combustion) of Costa Rica in 1974 and the CO2 emissions (% of total fuel combustion) of Cuba in 1978?
Offer a terse response. 40.8. What is the difference between the CO2 emissions (% of total fuel combustion) of Costa Rica in 1974 and the CO2 emissions (% of total fuel combustion) of Netherlands in 1978?
Provide a succinct answer. 43.78. What is the difference between the CO2 emissions (% of total fuel combustion) of Cuba in 1974 and the CO2 emissions (% of total fuel combustion) of Netherlands in 1978?
Give a very brief answer. 4.44. What is the difference between the CO2 emissions (% of total fuel combustion) of High income: OECD in 1975 and the CO2 emissions (% of total fuel combustion) of Costa Rica in 1976?
Your answer should be very brief. -38.83. What is the difference between the CO2 emissions (% of total fuel combustion) in High income: OECD in 1975 and the CO2 emissions (% of total fuel combustion) in Cuba in 1976?
Your answer should be compact. 2.37. What is the difference between the CO2 emissions (% of total fuel combustion) in High income: OECD in 1975 and the CO2 emissions (% of total fuel combustion) in Netherlands in 1976?
Your answer should be very brief. 6.25. What is the difference between the CO2 emissions (% of total fuel combustion) in Costa Rica in 1975 and the CO2 emissions (% of total fuel combustion) in Cuba in 1976?
Give a very brief answer. 38.41. What is the difference between the CO2 emissions (% of total fuel combustion) of Costa Rica in 1975 and the CO2 emissions (% of total fuel combustion) of Netherlands in 1976?
Ensure brevity in your answer.  42.29. What is the difference between the CO2 emissions (% of total fuel combustion) in Cuba in 1975 and the CO2 emissions (% of total fuel combustion) in Netherlands in 1976?
Make the answer very short. 4.56. What is the difference between the CO2 emissions (% of total fuel combustion) of High income: OECD in 1975 and the CO2 emissions (% of total fuel combustion) of Costa Rica in 1977?
Offer a very short reply. -30.26. What is the difference between the CO2 emissions (% of total fuel combustion) in High income: OECD in 1975 and the CO2 emissions (% of total fuel combustion) in Cuba in 1977?
Ensure brevity in your answer.  3.26. What is the difference between the CO2 emissions (% of total fuel combustion) of High income: OECD in 1975 and the CO2 emissions (% of total fuel combustion) of Netherlands in 1977?
Provide a short and direct response. 5.34. What is the difference between the CO2 emissions (% of total fuel combustion) in Costa Rica in 1975 and the CO2 emissions (% of total fuel combustion) in Cuba in 1977?
Give a very brief answer. 39.29. What is the difference between the CO2 emissions (% of total fuel combustion) of Costa Rica in 1975 and the CO2 emissions (% of total fuel combustion) of Netherlands in 1977?
Your answer should be compact. 41.37. What is the difference between the CO2 emissions (% of total fuel combustion) of Cuba in 1975 and the CO2 emissions (% of total fuel combustion) of Netherlands in 1977?
Your answer should be compact. 3.64. What is the difference between the CO2 emissions (% of total fuel combustion) of High income: OECD in 1975 and the CO2 emissions (% of total fuel combustion) of Costa Rica in 1978?
Ensure brevity in your answer.  -32.02. What is the difference between the CO2 emissions (% of total fuel combustion) in High income: OECD in 1975 and the CO2 emissions (% of total fuel combustion) in Cuba in 1978?
Provide a succinct answer. 3.72. What is the difference between the CO2 emissions (% of total fuel combustion) in High income: OECD in 1975 and the CO2 emissions (% of total fuel combustion) in Netherlands in 1978?
Your answer should be very brief. 6.7. What is the difference between the CO2 emissions (% of total fuel combustion) of Costa Rica in 1975 and the CO2 emissions (% of total fuel combustion) of Cuba in 1978?
Give a very brief answer. 39.75. What is the difference between the CO2 emissions (% of total fuel combustion) in Costa Rica in 1975 and the CO2 emissions (% of total fuel combustion) in Netherlands in 1978?
Provide a short and direct response. 42.74. What is the difference between the CO2 emissions (% of total fuel combustion) of Cuba in 1975 and the CO2 emissions (% of total fuel combustion) of Netherlands in 1978?
Provide a succinct answer. 5.01. What is the difference between the CO2 emissions (% of total fuel combustion) of High income: OECD in 1976 and the CO2 emissions (% of total fuel combustion) of Costa Rica in 1977?
Your answer should be compact. -30.49. What is the difference between the CO2 emissions (% of total fuel combustion) in High income: OECD in 1976 and the CO2 emissions (% of total fuel combustion) in Cuba in 1977?
Offer a very short reply. 3.03. What is the difference between the CO2 emissions (% of total fuel combustion) of High income: OECD in 1976 and the CO2 emissions (% of total fuel combustion) of Netherlands in 1977?
Ensure brevity in your answer.  5.1. What is the difference between the CO2 emissions (% of total fuel combustion) in Costa Rica in 1976 and the CO2 emissions (% of total fuel combustion) in Cuba in 1977?
Offer a terse response. 42.09. What is the difference between the CO2 emissions (% of total fuel combustion) of Costa Rica in 1976 and the CO2 emissions (% of total fuel combustion) of Netherlands in 1977?
Keep it short and to the point. 44.17. What is the difference between the CO2 emissions (% of total fuel combustion) in Cuba in 1976 and the CO2 emissions (% of total fuel combustion) in Netherlands in 1977?
Make the answer very short. 2.96. What is the difference between the CO2 emissions (% of total fuel combustion) in High income: OECD in 1976 and the CO2 emissions (% of total fuel combustion) in Costa Rica in 1978?
Offer a terse response. -32.25. What is the difference between the CO2 emissions (% of total fuel combustion) of High income: OECD in 1976 and the CO2 emissions (% of total fuel combustion) of Cuba in 1978?
Provide a short and direct response. 3.49. What is the difference between the CO2 emissions (% of total fuel combustion) of High income: OECD in 1976 and the CO2 emissions (% of total fuel combustion) of Netherlands in 1978?
Make the answer very short. 6.47. What is the difference between the CO2 emissions (% of total fuel combustion) of Costa Rica in 1976 and the CO2 emissions (% of total fuel combustion) of Cuba in 1978?
Your response must be concise. 42.55. What is the difference between the CO2 emissions (% of total fuel combustion) in Costa Rica in 1976 and the CO2 emissions (% of total fuel combustion) in Netherlands in 1978?
Ensure brevity in your answer.  45.53. What is the difference between the CO2 emissions (% of total fuel combustion) in Cuba in 1976 and the CO2 emissions (% of total fuel combustion) in Netherlands in 1978?
Give a very brief answer. 4.33. What is the difference between the CO2 emissions (% of total fuel combustion) of High income: OECD in 1977 and the CO2 emissions (% of total fuel combustion) of Costa Rica in 1978?
Make the answer very short. -32.04. What is the difference between the CO2 emissions (% of total fuel combustion) of High income: OECD in 1977 and the CO2 emissions (% of total fuel combustion) of Cuba in 1978?
Your response must be concise. 3.7. What is the difference between the CO2 emissions (% of total fuel combustion) of High income: OECD in 1977 and the CO2 emissions (% of total fuel combustion) of Netherlands in 1978?
Your response must be concise. 6.68. What is the difference between the CO2 emissions (% of total fuel combustion) in Costa Rica in 1977 and the CO2 emissions (% of total fuel combustion) in Cuba in 1978?
Your answer should be very brief. 33.98. What is the difference between the CO2 emissions (% of total fuel combustion) in Costa Rica in 1977 and the CO2 emissions (% of total fuel combustion) in Netherlands in 1978?
Ensure brevity in your answer.  36.96. What is the difference between the CO2 emissions (% of total fuel combustion) of Cuba in 1977 and the CO2 emissions (% of total fuel combustion) of Netherlands in 1978?
Make the answer very short. 3.44. What is the average CO2 emissions (% of total fuel combustion) of High income: OECD per year?
Your response must be concise. 20.03. What is the average CO2 emissions (% of total fuel combustion) in Costa Rica per year?
Give a very brief answer. 54.49. What is the average CO2 emissions (% of total fuel combustion) of Cuba per year?
Give a very brief answer. 18.75. What is the average CO2 emissions (% of total fuel combustion) in Netherlands per year?
Provide a succinct answer. 13.38. In the year 1971, what is the difference between the CO2 emissions (% of total fuel combustion) in High income: OECD and CO2 emissions (% of total fuel combustion) in Costa Rica?
Give a very brief answer. -34.05. In the year 1971, what is the difference between the CO2 emissions (% of total fuel combustion) of High income: OECD and CO2 emissions (% of total fuel combustion) of Cuba?
Your answer should be very brief. -0.81. In the year 1971, what is the difference between the CO2 emissions (% of total fuel combustion) in High income: OECD and CO2 emissions (% of total fuel combustion) in Netherlands?
Provide a succinct answer. 6.1. In the year 1971, what is the difference between the CO2 emissions (% of total fuel combustion) in Costa Rica and CO2 emissions (% of total fuel combustion) in Cuba?
Your response must be concise. 33.23. In the year 1971, what is the difference between the CO2 emissions (% of total fuel combustion) in Costa Rica and CO2 emissions (% of total fuel combustion) in Netherlands?
Your answer should be very brief. 40.15. In the year 1971, what is the difference between the CO2 emissions (% of total fuel combustion) in Cuba and CO2 emissions (% of total fuel combustion) in Netherlands?
Ensure brevity in your answer.  6.92. In the year 1972, what is the difference between the CO2 emissions (% of total fuel combustion) of High income: OECD and CO2 emissions (% of total fuel combustion) of Costa Rica?
Keep it short and to the point. -34.52. In the year 1972, what is the difference between the CO2 emissions (% of total fuel combustion) of High income: OECD and CO2 emissions (% of total fuel combustion) of Cuba?
Your response must be concise. -0.59. In the year 1972, what is the difference between the CO2 emissions (% of total fuel combustion) of High income: OECD and CO2 emissions (% of total fuel combustion) of Netherlands?
Provide a succinct answer. 6.97. In the year 1972, what is the difference between the CO2 emissions (% of total fuel combustion) in Costa Rica and CO2 emissions (% of total fuel combustion) in Cuba?
Provide a succinct answer. 33.93. In the year 1972, what is the difference between the CO2 emissions (% of total fuel combustion) of Costa Rica and CO2 emissions (% of total fuel combustion) of Netherlands?
Offer a terse response. 41.49. In the year 1972, what is the difference between the CO2 emissions (% of total fuel combustion) in Cuba and CO2 emissions (% of total fuel combustion) in Netherlands?
Give a very brief answer. 7.56. In the year 1973, what is the difference between the CO2 emissions (% of total fuel combustion) in High income: OECD and CO2 emissions (% of total fuel combustion) in Costa Rica?
Offer a very short reply. -32.12. In the year 1973, what is the difference between the CO2 emissions (% of total fuel combustion) in High income: OECD and CO2 emissions (% of total fuel combustion) in Cuba?
Ensure brevity in your answer.  -0.92. In the year 1973, what is the difference between the CO2 emissions (% of total fuel combustion) of High income: OECD and CO2 emissions (% of total fuel combustion) of Netherlands?
Keep it short and to the point. 6.98. In the year 1973, what is the difference between the CO2 emissions (% of total fuel combustion) of Costa Rica and CO2 emissions (% of total fuel combustion) of Cuba?
Provide a succinct answer. 31.21. In the year 1973, what is the difference between the CO2 emissions (% of total fuel combustion) in Costa Rica and CO2 emissions (% of total fuel combustion) in Netherlands?
Ensure brevity in your answer.  39.1. In the year 1973, what is the difference between the CO2 emissions (% of total fuel combustion) of Cuba and CO2 emissions (% of total fuel combustion) of Netherlands?
Your answer should be very brief. 7.89. In the year 1974, what is the difference between the CO2 emissions (% of total fuel combustion) of High income: OECD and CO2 emissions (% of total fuel combustion) of Costa Rica?
Your answer should be very brief. -38.17. In the year 1974, what is the difference between the CO2 emissions (% of total fuel combustion) of High income: OECD and CO2 emissions (% of total fuel combustion) of Cuba?
Provide a succinct answer. 1.17. In the year 1974, what is the difference between the CO2 emissions (% of total fuel combustion) of High income: OECD and CO2 emissions (% of total fuel combustion) of Netherlands?
Make the answer very short. 7.41. In the year 1974, what is the difference between the CO2 emissions (% of total fuel combustion) in Costa Rica and CO2 emissions (% of total fuel combustion) in Cuba?
Offer a very short reply. 39.34. In the year 1974, what is the difference between the CO2 emissions (% of total fuel combustion) in Costa Rica and CO2 emissions (% of total fuel combustion) in Netherlands?
Offer a terse response. 45.58. In the year 1974, what is the difference between the CO2 emissions (% of total fuel combustion) of Cuba and CO2 emissions (% of total fuel combustion) of Netherlands?
Offer a very short reply. 6.24. In the year 1975, what is the difference between the CO2 emissions (% of total fuel combustion) of High income: OECD and CO2 emissions (% of total fuel combustion) of Costa Rica?
Give a very brief answer. -36.03. In the year 1975, what is the difference between the CO2 emissions (% of total fuel combustion) of High income: OECD and CO2 emissions (% of total fuel combustion) of Cuba?
Keep it short and to the point. 1.69. In the year 1975, what is the difference between the CO2 emissions (% of total fuel combustion) in High income: OECD and CO2 emissions (% of total fuel combustion) in Netherlands?
Make the answer very short. 7.1. In the year 1975, what is the difference between the CO2 emissions (% of total fuel combustion) of Costa Rica and CO2 emissions (% of total fuel combustion) of Cuba?
Ensure brevity in your answer.  37.73. In the year 1975, what is the difference between the CO2 emissions (% of total fuel combustion) in Costa Rica and CO2 emissions (% of total fuel combustion) in Netherlands?
Your answer should be compact. 43.14. In the year 1975, what is the difference between the CO2 emissions (% of total fuel combustion) in Cuba and CO2 emissions (% of total fuel combustion) in Netherlands?
Your answer should be very brief. 5.41. In the year 1976, what is the difference between the CO2 emissions (% of total fuel combustion) in High income: OECD and CO2 emissions (% of total fuel combustion) in Costa Rica?
Your response must be concise. -39.07. In the year 1976, what is the difference between the CO2 emissions (% of total fuel combustion) in High income: OECD and CO2 emissions (% of total fuel combustion) in Cuba?
Provide a short and direct response. 2.14. In the year 1976, what is the difference between the CO2 emissions (% of total fuel combustion) of High income: OECD and CO2 emissions (% of total fuel combustion) of Netherlands?
Your answer should be compact. 6.02. In the year 1976, what is the difference between the CO2 emissions (% of total fuel combustion) in Costa Rica and CO2 emissions (% of total fuel combustion) in Cuba?
Keep it short and to the point. 41.2. In the year 1976, what is the difference between the CO2 emissions (% of total fuel combustion) of Costa Rica and CO2 emissions (% of total fuel combustion) of Netherlands?
Keep it short and to the point. 45.08. In the year 1976, what is the difference between the CO2 emissions (% of total fuel combustion) of Cuba and CO2 emissions (% of total fuel combustion) of Netherlands?
Offer a very short reply. 3.88. In the year 1977, what is the difference between the CO2 emissions (% of total fuel combustion) of High income: OECD and CO2 emissions (% of total fuel combustion) of Costa Rica?
Your response must be concise. -30.28. In the year 1977, what is the difference between the CO2 emissions (% of total fuel combustion) in High income: OECD and CO2 emissions (% of total fuel combustion) in Cuba?
Keep it short and to the point. 3.24. In the year 1977, what is the difference between the CO2 emissions (% of total fuel combustion) in High income: OECD and CO2 emissions (% of total fuel combustion) in Netherlands?
Your response must be concise. 5.31. In the year 1977, what is the difference between the CO2 emissions (% of total fuel combustion) in Costa Rica and CO2 emissions (% of total fuel combustion) in Cuba?
Your response must be concise. 33.52. In the year 1977, what is the difference between the CO2 emissions (% of total fuel combustion) of Costa Rica and CO2 emissions (% of total fuel combustion) of Netherlands?
Give a very brief answer. 35.59. In the year 1977, what is the difference between the CO2 emissions (% of total fuel combustion) in Cuba and CO2 emissions (% of total fuel combustion) in Netherlands?
Your answer should be very brief. 2.07. In the year 1978, what is the difference between the CO2 emissions (% of total fuel combustion) in High income: OECD and CO2 emissions (% of total fuel combustion) in Costa Rica?
Make the answer very short. -31.42. In the year 1978, what is the difference between the CO2 emissions (% of total fuel combustion) of High income: OECD and CO2 emissions (% of total fuel combustion) of Cuba?
Make the answer very short. 4.32. In the year 1978, what is the difference between the CO2 emissions (% of total fuel combustion) of High income: OECD and CO2 emissions (% of total fuel combustion) of Netherlands?
Provide a succinct answer. 7.3. In the year 1978, what is the difference between the CO2 emissions (% of total fuel combustion) of Costa Rica and CO2 emissions (% of total fuel combustion) of Cuba?
Your answer should be compact. 35.74. In the year 1978, what is the difference between the CO2 emissions (% of total fuel combustion) of Costa Rica and CO2 emissions (% of total fuel combustion) of Netherlands?
Provide a short and direct response. 38.72. In the year 1978, what is the difference between the CO2 emissions (% of total fuel combustion) of Cuba and CO2 emissions (% of total fuel combustion) of Netherlands?
Ensure brevity in your answer.  2.98. What is the ratio of the CO2 emissions (% of total fuel combustion) in Costa Rica in 1971 to that in 1972?
Offer a very short reply. 0.99. What is the ratio of the CO2 emissions (% of total fuel combustion) in Netherlands in 1971 to that in 1972?
Provide a succinct answer. 1.05. What is the ratio of the CO2 emissions (% of total fuel combustion) of High income: OECD in 1971 to that in 1973?
Offer a terse response. 0.98. What is the ratio of the CO2 emissions (% of total fuel combustion) of Costa Rica in 1971 to that in 1973?
Give a very brief answer. 1.03. What is the ratio of the CO2 emissions (% of total fuel combustion) of Cuba in 1971 to that in 1973?
Make the answer very short. 0.98. What is the ratio of the CO2 emissions (% of total fuel combustion) in Netherlands in 1971 to that in 1973?
Make the answer very short. 1.05. What is the ratio of the CO2 emissions (% of total fuel combustion) of High income: OECD in 1971 to that in 1974?
Provide a short and direct response. 0.98. What is the ratio of the CO2 emissions (% of total fuel combustion) of Costa Rica in 1971 to that in 1974?
Your response must be concise. 0.92. What is the ratio of the CO2 emissions (% of total fuel combustion) in Cuba in 1971 to that in 1974?
Ensure brevity in your answer.  1.09. What is the ratio of the CO2 emissions (% of total fuel combustion) in Netherlands in 1971 to that in 1974?
Provide a succinct answer. 1.08. What is the ratio of the CO2 emissions (% of total fuel combustion) in High income: OECD in 1971 to that in 1975?
Your response must be concise. 0.93. What is the ratio of the CO2 emissions (% of total fuel combustion) of Costa Rica in 1971 to that in 1975?
Provide a succinct answer. 0.94. What is the ratio of the CO2 emissions (% of total fuel combustion) of Cuba in 1971 to that in 1975?
Offer a very short reply. 1.05. What is the ratio of the CO2 emissions (% of total fuel combustion) in Netherlands in 1971 to that in 1975?
Your response must be concise. 0.96. What is the ratio of the CO2 emissions (% of total fuel combustion) in High income: OECD in 1971 to that in 1976?
Your response must be concise. 0.94. What is the ratio of the CO2 emissions (% of total fuel combustion) in Costa Rica in 1971 to that in 1976?
Provide a succinct answer. 0.89. What is the ratio of the CO2 emissions (% of total fuel combustion) of Cuba in 1971 to that in 1976?
Give a very brief answer. 1.09. What is the ratio of the CO2 emissions (% of total fuel combustion) in Netherlands in 1971 to that in 1976?
Your answer should be very brief. 0.91. What is the ratio of the CO2 emissions (% of total fuel combustion) of High income: OECD in 1971 to that in 1977?
Offer a very short reply. 0.93. What is the ratio of the CO2 emissions (% of total fuel combustion) of Costa Rica in 1971 to that in 1977?
Offer a very short reply. 1.05. What is the ratio of the CO2 emissions (% of total fuel combustion) in Cuba in 1971 to that in 1977?
Offer a very short reply. 1.15. What is the ratio of the CO2 emissions (% of total fuel combustion) in Netherlands in 1971 to that in 1977?
Keep it short and to the point. 0.85. What is the ratio of the CO2 emissions (% of total fuel combustion) in High income: OECD in 1971 to that in 1978?
Your response must be concise. 0.9. What is the ratio of the CO2 emissions (% of total fuel combustion) in Costa Rica in 1971 to that in 1978?
Make the answer very short. 1.01. What is the ratio of the CO2 emissions (% of total fuel combustion) of Cuba in 1971 to that in 1978?
Make the answer very short. 1.18. What is the ratio of the CO2 emissions (% of total fuel combustion) in Netherlands in 1971 to that in 1978?
Provide a short and direct response. 0.94. What is the ratio of the CO2 emissions (% of total fuel combustion) in Costa Rica in 1972 to that in 1973?
Your answer should be very brief. 1.05. What is the ratio of the CO2 emissions (% of total fuel combustion) of Cuba in 1972 to that in 1973?
Ensure brevity in your answer.  0.98. What is the ratio of the CO2 emissions (% of total fuel combustion) of Netherlands in 1972 to that in 1973?
Offer a terse response. 1. What is the ratio of the CO2 emissions (% of total fuel combustion) of Costa Rica in 1972 to that in 1974?
Your answer should be very brief. 0.93. What is the ratio of the CO2 emissions (% of total fuel combustion) in Cuba in 1972 to that in 1974?
Your response must be concise. 1.09. What is the ratio of the CO2 emissions (% of total fuel combustion) in Netherlands in 1972 to that in 1974?
Your answer should be very brief. 1.02. What is the ratio of the CO2 emissions (% of total fuel combustion) of High income: OECD in 1972 to that in 1975?
Your answer should be very brief. 0.94. What is the ratio of the CO2 emissions (% of total fuel combustion) of Costa Rica in 1972 to that in 1975?
Provide a short and direct response. 0.95. What is the ratio of the CO2 emissions (% of total fuel combustion) of Cuba in 1972 to that in 1975?
Keep it short and to the point. 1.06. What is the ratio of the CO2 emissions (% of total fuel combustion) of Netherlands in 1972 to that in 1975?
Give a very brief answer. 0.92. What is the ratio of the CO2 emissions (% of total fuel combustion) of High income: OECD in 1972 to that in 1976?
Your answer should be compact. 0.95. What is the ratio of the CO2 emissions (% of total fuel combustion) of Costa Rica in 1972 to that in 1976?
Provide a short and direct response. 0.91. What is the ratio of the CO2 emissions (% of total fuel combustion) in Cuba in 1972 to that in 1976?
Provide a succinct answer. 1.09. What is the ratio of the CO2 emissions (% of total fuel combustion) of Netherlands in 1972 to that in 1976?
Ensure brevity in your answer.  0.86. What is the ratio of the CO2 emissions (% of total fuel combustion) in High income: OECD in 1972 to that in 1977?
Provide a short and direct response. 0.94. What is the ratio of the CO2 emissions (% of total fuel combustion) of Costa Rica in 1972 to that in 1977?
Make the answer very short. 1.06. What is the ratio of the CO2 emissions (% of total fuel combustion) in Cuba in 1972 to that in 1977?
Offer a very short reply. 1.15. What is the ratio of the CO2 emissions (% of total fuel combustion) of Netherlands in 1972 to that in 1977?
Your answer should be very brief. 0.81. What is the ratio of the CO2 emissions (% of total fuel combustion) in High income: OECD in 1972 to that in 1978?
Offer a terse response. 0.91. What is the ratio of the CO2 emissions (% of total fuel combustion) of Costa Rica in 1972 to that in 1978?
Your answer should be very brief. 1.02. What is the ratio of the CO2 emissions (% of total fuel combustion) in Cuba in 1972 to that in 1978?
Make the answer very short. 1.18. What is the ratio of the CO2 emissions (% of total fuel combustion) in Netherlands in 1972 to that in 1978?
Offer a terse response. 0.89. What is the ratio of the CO2 emissions (% of total fuel combustion) of Costa Rica in 1973 to that in 1974?
Your response must be concise. 0.89. What is the ratio of the CO2 emissions (% of total fuel combustion) in Cuba in 1973 to that in 1974?
Keep it short and to the point. 1.11. What is the ratio of the CO2 emissions (% of total fuel combustion) of Netherlands in 1973 to that in 1974?
Ensure brevity in your answer.  1.03. What is the ratio of the CO2 emissions (% of total fuel combustion) in High income: OECD in 1973 to that in 1975?
Provide a short and direct response. 0.94. What is the ratio of the CO2 emissions (% of total fuel combustion) in Costa Rica in 1973 to that in 1975?
Provide a short and direct response. 0.91. What is the ratio of the CO2 emissions (% of total fuel combustion) of Cuba in 1973 to that in 1975?
Keep it short and to the point. 1.08. What is the ratio of the CO2 emissions (% of total fuel combustion) of Netherlands in 1973 to that in 1975?
Provide a short and direct response. 0.92. What is the ratio of the CO2 emissions (% of total fuel combustion) in High income: OECD in 1973 to that in 1976?
Make the answer very short. 0.95. What is the ratio of the CO2 emissions (% of total fuel combustion) of Costa Rica in 1973 to that in 1976?
Give a very brief answer. 0.87. What is the ratio of the CO2 emissions (% of total fuel combustion) in Cuba in 1973 to that in 1976?
Your answer should be very brief. 1.12. What is the ratio of the CO2 emissions (% of total fuel combustion) of Netherlands in 1973 to that in 1976?
Give a very brief answer. 0.87. What is the ratio of the CO2 emissions (% of total fuel combustion) in High income: OECD in 1973 to that in 1977?
Your answer should be very brief. 0.94. What is the ratio of the CO2 emissions (% of total fuel combustion) of Costa Rica in 1973 to that in 1977?
Your response must be concise. 1.01. What is the ratio of the CO2 emissions (% of total fuel combustion) in Cuba in 1973 to that in 1977?
Your response must be concise. 1.17. What is the ratio of the CO2 emissions (% of total fuel combustion) in Netherlands in 1973 to that in 1977?
Ensure brevity in your answer.  0.81. What is the ratio of the CO2 emissions (% of total fuel combustion) of High income: OECD in 1973 to that in 1978?
Offer a very short reply. 0.92. What is the ratio of the CO2 emissions (% of total fuel combustion) in Costa Rica in 1973 to that in 1978?
Your answer should be very brief. 0.98. What is the ratio of the CO2 emissions (% of total fuel combustion) of Cuba in 1973 to that in 1978?
Make the answer very short. 1.2. What is the ratio of the CO2 emissions (% of total fuel combustion) in Netherlands in 1973 to that in 1978?
Provide a succinct answer. 0.9. What is the ratio of the CO2 emissions (% of total fuel combustion) of High income: OECD in 1974 to that in 1975?
Your answer should be very brief. 0.95. What is the ratio of the CO2 emissions (% of total fuel combustion) in Costa Rica in 1974 to that in 1975?
Offer a very short reply. 1.02. What is the ratio of the CO2 emissions (% of total fuel combustion) of Cuba in 1974 to that in 1975?
Offer a terse response. 0.97. What is the ratio of the CO2 emissions (% of total fuel combustion) in Netherlands in 1974 to that in 1975?
Keep it short and to the point. 0.9. What is the ratio of the CO2 emissions (% of total fuel combustion) in High income: OECD in 1974 to that in 1976?
Provide a short and direct response. 0.96. What is the ratio of the CO2 emissions (% of total fuel combustion) in Costa Rica in 1974 to that in 1976?
Make the answer very short. 0.97. What is the ratio of the CO2 emissions (% of total fuel combustion) of Netherlands in 1974 to that in 1976?
Offer a very short reply. 0.84. What is the ratio of the CO2 emissions (% of total fuel combustion) in High income: OECD in 1974 to that in 1977?
Offer a terse response. 0.95. What is the ratio of the CO2 emissions (% of total fuel combustion) in Costa Rica in 1974 to that in 1977?
Make the answer very short. 1.13. What is the ratio of the CO2 emissions (% of total fuel combustion) in Cuba in 1974 to that in 1977?
Ensure brevity in your answer.  1.06. What is the ratio of the CO2 emissions (% of total fuel combustion) in Netherlands in 1974 to that in 1977?
Your answer should be very brief. 0.79. What is the ratio of the CO2 emissions (% of total fuel combustion) in High income: OECD in 1974 to that in 1978?
Your response must be concise. 0.92. What is the ratio of the CO2 emissions (% of total fuel combustion) of Costa Rica in 1974 to that in 1978?
Make the answer very short. 1.1. What is the ratio of the CO2 emissions (% of total fuel combustion) in Cuba in 1974 to that in 1978?
Give a very brief answer. 1.09. What is the ratio of the CO2 emissions (% of total fuel combustion) in Netherlands in 1974 to that in 1978?
Your answer should be very brief. 0.87. What is the ratio of the CO2 emissions (% of total fuel combustion) in High income: OECD in 1975 to that in 1976?
Your answer should be compact. 1.01. What is the ratio of the CO2 emissions (% of total fuel combustion) of Costa Rica in 1975 to that in 1976?
Keep it short and to the point. 0.95. What is the ratio of the CO2 emissions (% of total fuel combustion) in Cuba in 1975 to that in 1976?
Your answer should be compact. 1.04. What is the ratio of the CO2 emissions (% of total fuel combustion) in Netherlands in 1975 to that in 1976?
Make the answer very short. 0.94. What is the ratio of the CO2 emissions (% of total fuel combustion) in High income: OECD in 1975 to that in 1977?
Provide a succinct answer. 1. What is the ratio of the CO2 emissions (% of total fuel combustion) in Costa Rica in 1975 to that in 1977?
Your response must be concise. 1.11. What is the ratio of the CO2 emissions (% of total fuel combustion) of Cuba in 1975 to that in 1977?
Your answer should be very brief. 1.09. What is the ratio of the CO2 emissions (% of total fuel combustion) in Netherlands in 1975 to that in 1977?
Your response must be concise. 0.88. What is the ratio of the CO2 emissions (% of total fuel combustion) of High income: OECD in 1975 to that in 1978?
Give a very brief answer. 0.97. What is the ratio of the CO2 emissions (% of total fuel combustion) in Costa Rica in 1975 to that in 1978?
Offer a terse response. 1.08. What is the ratio of the CO2 emissions (% of total fuel combustion) of Cuba in 1975 to that in 1978?
Offer a very short reply. 1.12. What is the ratio of the CO2 emissions (% of total fuel combustion) of Netherlands in 1975 to that in 1978?
Your answer should be very brief. 0.97. What is the ratio of the CO2 emissions (% of total fuel combustion) of High income: OECD in 1976 to that in 1977?
Offer a terse response. 0.99. What is the ratio of the CO2 emissions (% of total fuel combustion) of Costa Rica in 1976 to that in 1977?
Offer a very short reply. 1.17. What is the ratio of the CO2 emissions (% of total fuel combustion) in Cuba in 1976 to that in 1977?
Provide a succinct answer. 1.05. What is the ratio of the CO2 emissions (% of total fuel combustion) of Netherlands in 1976 to that in 1977?
Provide a short and direct response. 0.94. What is the ratio of the CO2 emissions (% of total fuel combustion) in High income: OECD in 1976 to that in 1978?
Your response must be concise. 0.96. What is the ratio of the CO2 emissions (% of total fuel combustion) of Costa Rica in 1976 to that in 1978?
Offer a very short reply. 1.13. What is the ratio of the CO2 emissions (% of total fuel combustion) in Cuba in 1976 to that in 1978?
Provide a short and direct response. 1.08. What is the ratio of the CO2 emissions (% of total fuel combustion) in Netherlands in 1976 to that in 1978?
Give a very brief answer. 1.03. What is the ratio of the CO2 emissions (% of total fuel combustion) in High income: OECD in 1977 to that in 1978?
Offer a very short reply. 0.97. What is the ratio of the CO2 emissions (% of total fuel combustion) in Costa Rica in 1977 to that in 1978?
Ensure brevity in your answer.  0.97. What is the ratio of the CO2 emissions (% of total fuel combustion) of Cuba in 1977 to that in 1978?
Provide a succinct answer. 1.03. What is the ratio of the CO2 emissions (% of total fuel combustion) in Netherlands in 1977 to that in 1978?
Ensure brevity in your answer.  1.1. What is the difference between the highest and the second highest CO2 emissions (% of total fuel combustion) of High income: OECD?
Provide a short and direct response. 0.6. What is the difference between the highest and the second highest CO2 emissions (% of total fuel combustion) of Costa Rica?
Your answer should be very brief. 1.75. What is the difference between the highest and the second highest CO2 emissions (% of total fuel combustion) in Cuba?
Keep it short and to the point. 0.37. What is the difference between the highest and the second highest CO2 emissions (% of total fuel combustion) in Netherlands?
Your answer should be compact. 0.92. What is the difference between the highest and the lowest CO2 emissions (% of total fuel combustion) in High income: OECD?
Provide a short and direct response. 2.08. What is the difference between the highest and the lowest CO2 emissions (% of total fuel combustion) in Costa Rica?
Your response must be concise. 8.57. What is the difference between the highest and the lowest CO2 emissions (% of total fuel combustion) in Cuba?
Offer a terse response. 3.45. What is the difference between the highest and the lowest CO2 emissions (% of total fuel combustion) in Netherlands?
Your response must be concise. 3.16. 